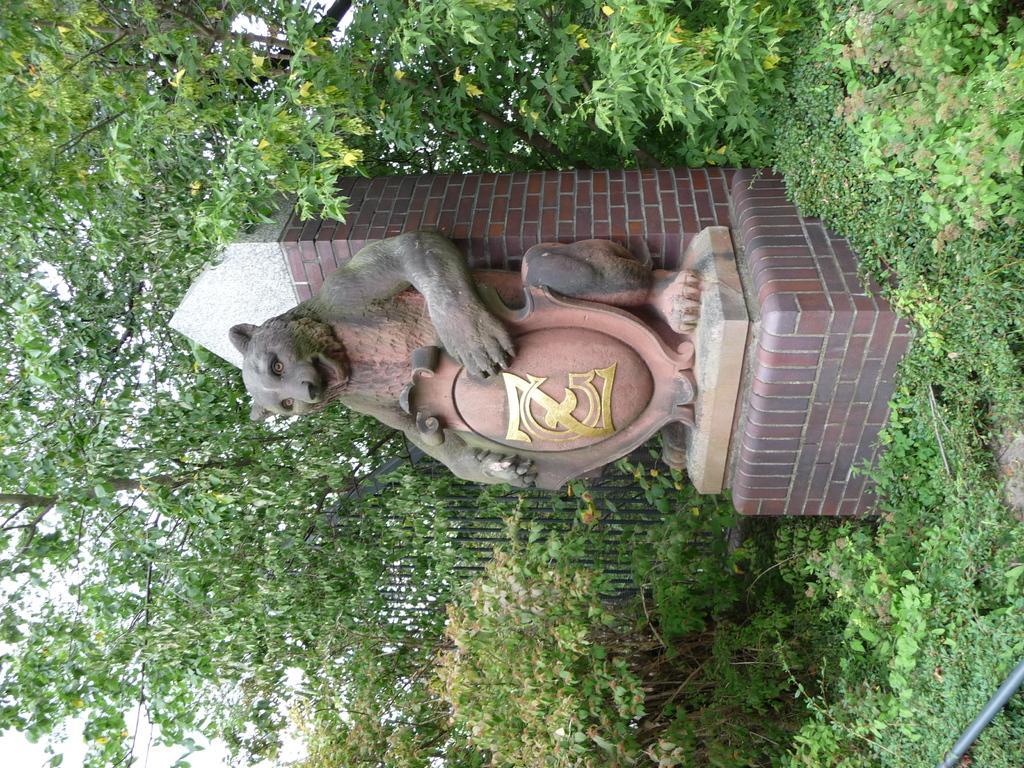Can you describe this image briefly? In the center of the image there is a depiction of a animal. In the background of the image there are trees. At the bottom of the image there are plants. 